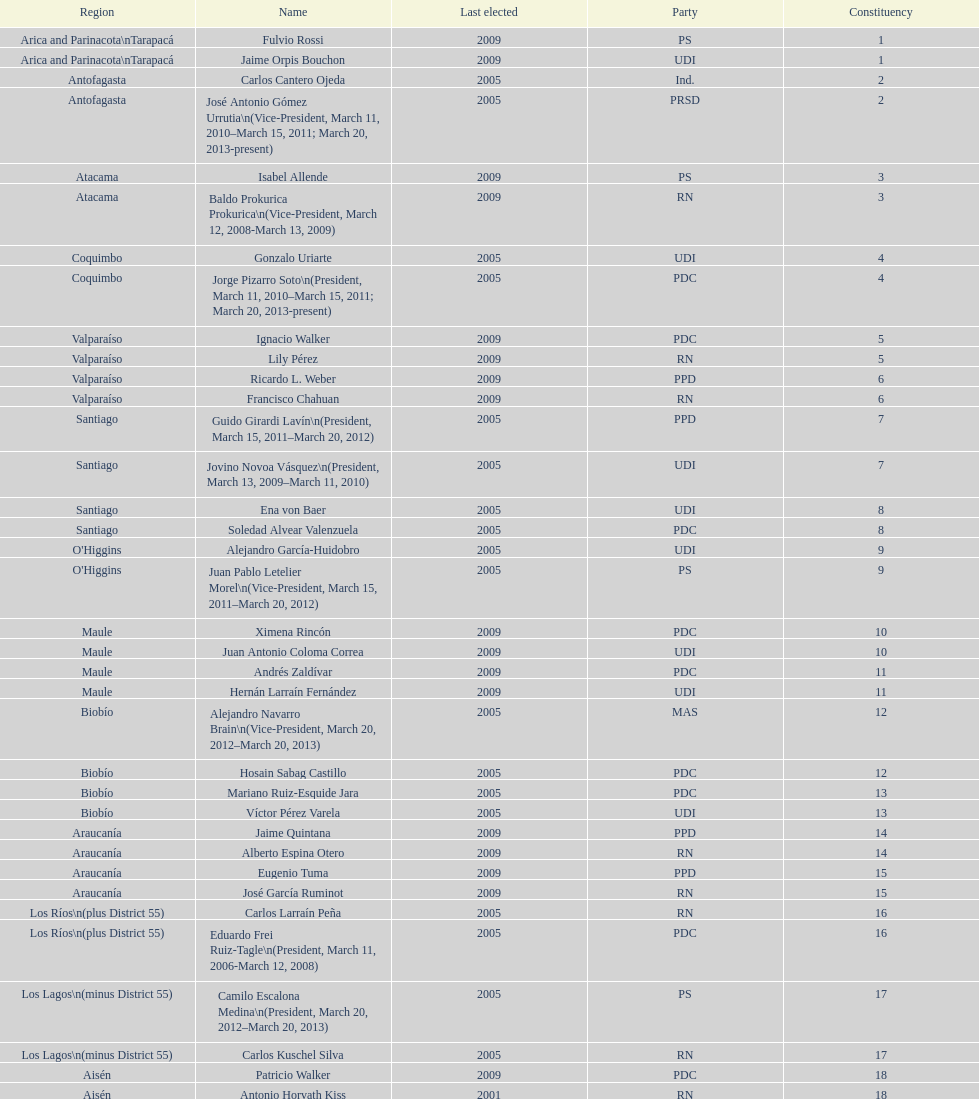When was antonio horvath kiss last elected? 2001. 